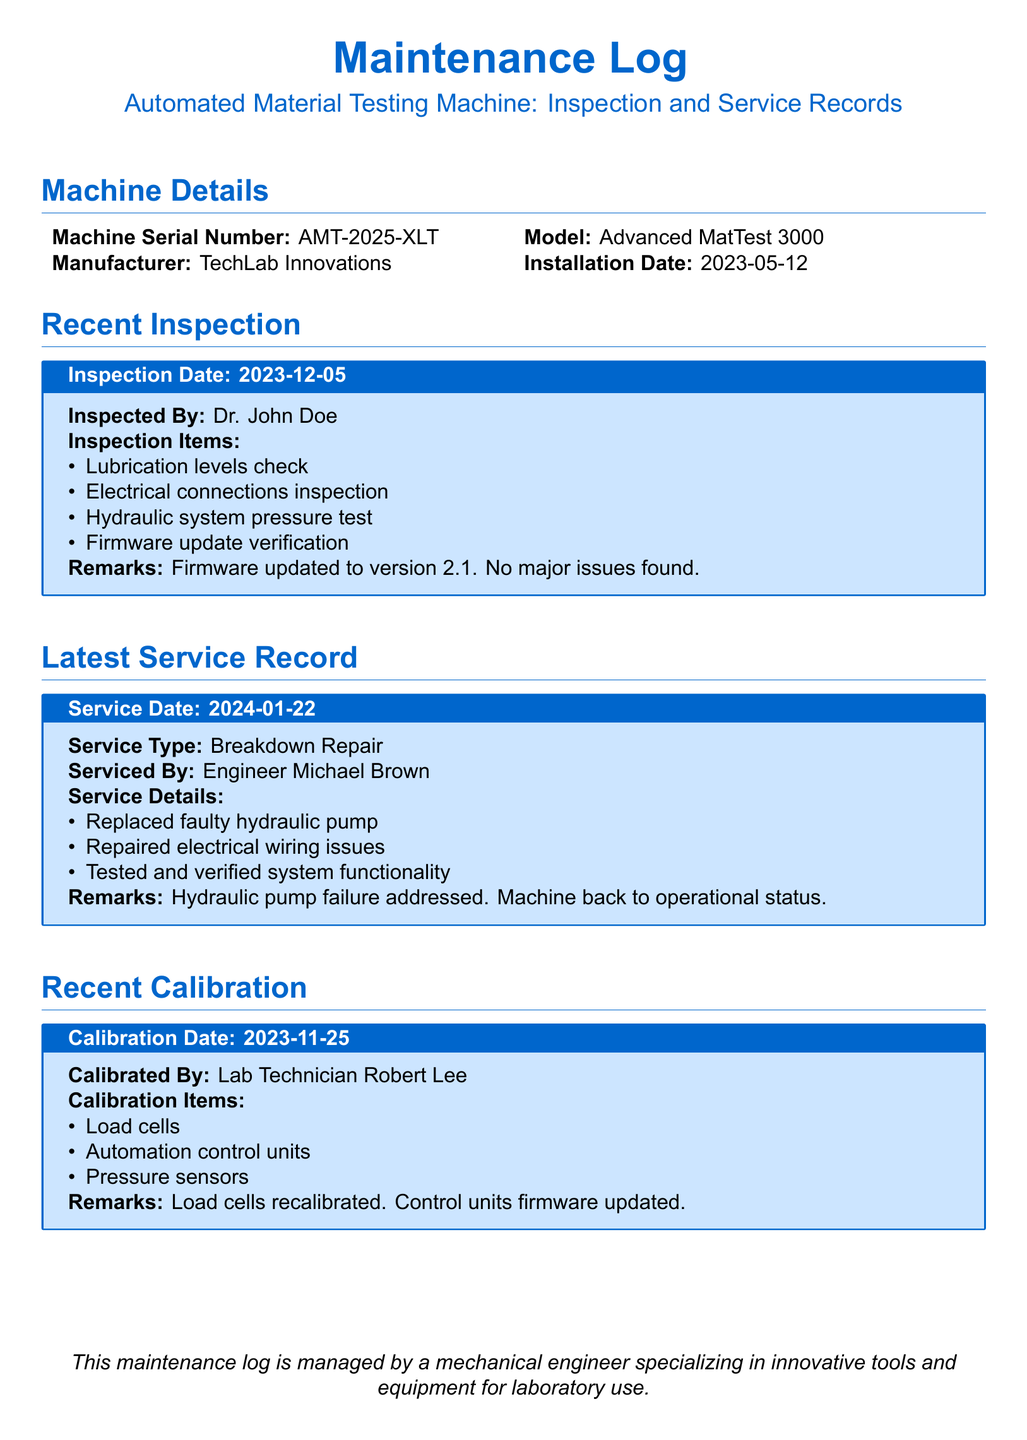what is the machine serial number? The machine serial number is stated in the 'Machine Details' section of the document.
Answer: AMT-2025-XLT who inspected the machine on December 5, 2023? The name of the inspector can be found in the 'Recent Inspection' section.
Answer: Dr. John Doe what service type was performed on January 22, 2024? The type of service is listed in the 'Latest Service Record' section of the document.
Answer: Breakdown Repair when was the last calibration conducted? The calibration date is specified in the 'Recent Calibration' section.
Answer: 2023-11-25 how many items were checked during the inspection? The number of inspection items can be counted from the list in the 'Recent Inspection' section.
Answer: Four who calibrated the machine? The name of the person who calibrated the machine is provided in the 'Recent Calibration' section.
Answer: Lab Technician Robert Lee what was the major issue addressed during the latest service? The major issue is highlighted in the 'Latest Service Record' section.
Answer: Hydraulic pump failure what firmware version was the machine updated to during the last inspection? The firmware version is mentioned in the 'Recent Inspection' section.
Answer: 2.1 